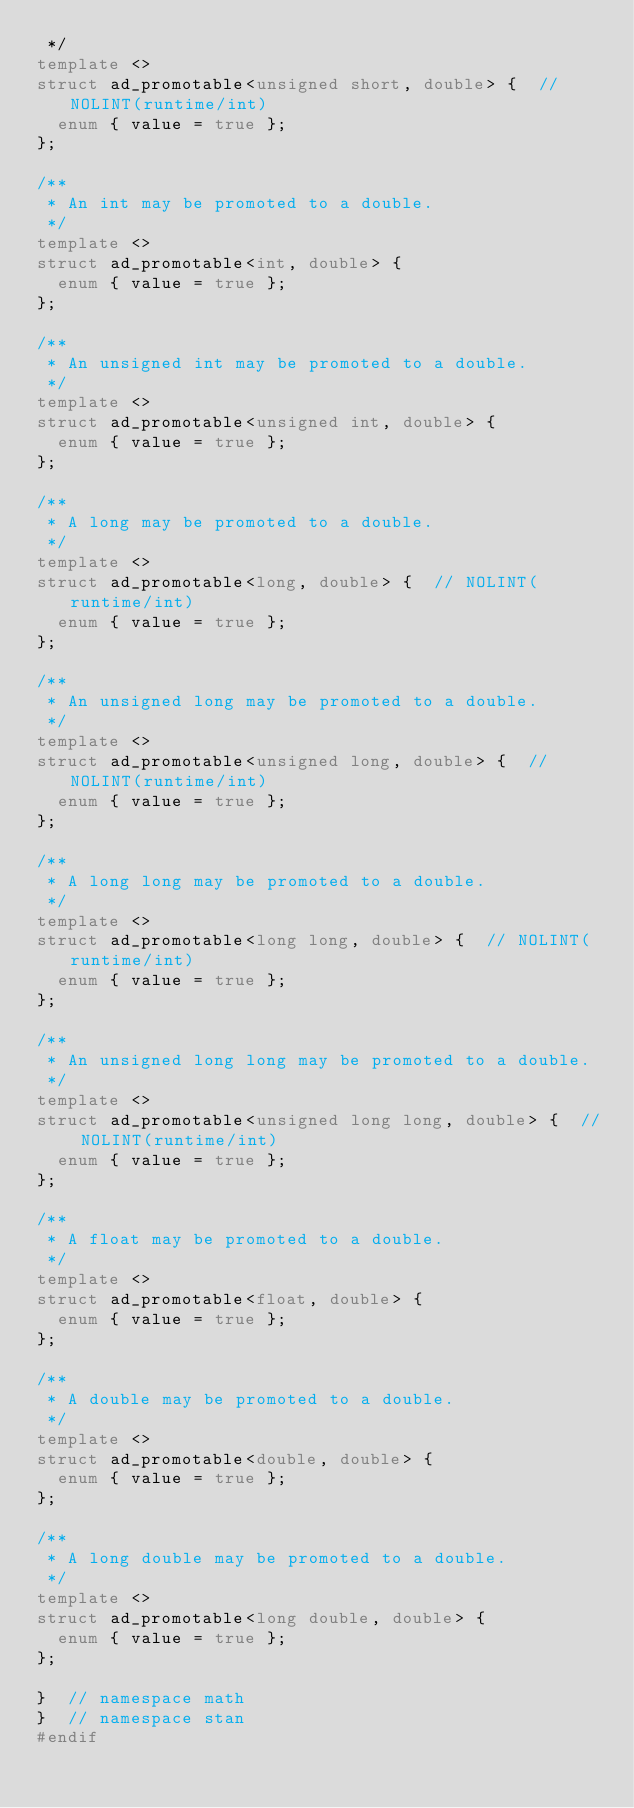Convert code to text. <code><loc_0><loc_0><loc_500><loc_500><_C++_> */
template <>
struct ad_promotable<unsigned short, double> {  // NOLINT(runtime/int)
  enum { value = true };
};

/**
 * An int may be promoted to a double.
 */
template <>
struct ad_promotable<int, double> {
  enum { value = true };
};

/**
 * An unsigned int may be promoted to a double.
 */
template <>
struct ad_promotable<unsigned int, double> {
  enum { value = true };
};

/**
 * A long may be promoted to a double.
 */
template <>
struct ad_promotable<long, double> {  // NOLINT(runtime/int)
  enum { value = true };
};

/**
 * An unsigned long may be promoted to a double.
 */
template <>
struct ad_promotable<unsigned long, double> {  // NOLINT(runtime/int)
  enum { value = true };
};

/**
 * A long long may be promoted to a double.
 */
template <>
struct ad_promotable<long long, double> {  // NOLINT(runtime/int)
  enum { value = true };
};

/**
 * An unsigned long long may be promoted to a double.
 */
template <>
struct ad_promotable<unsigned long long, double> {  // NOLINT(runtime/int)
  enum { value = true };
};

/**
 * A float may be promoted to a double.
 */
template <>
struct ad_promotable<float, double> {
  enum { value = true };
};

/**
 * A double may be promoted to a double.
 */
template <>
struct ad_promotable<double, double> {
  enum { value = true };
};

/**
 * A long double may be promoted to a double.
 */
template <>
struct ad_promotable<long double, double> {
  enum { value = true };
};

}  // namespace math
}  // namespace stan
#endif
</code> 